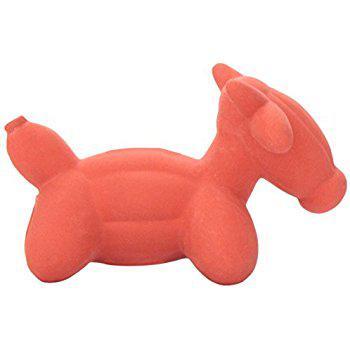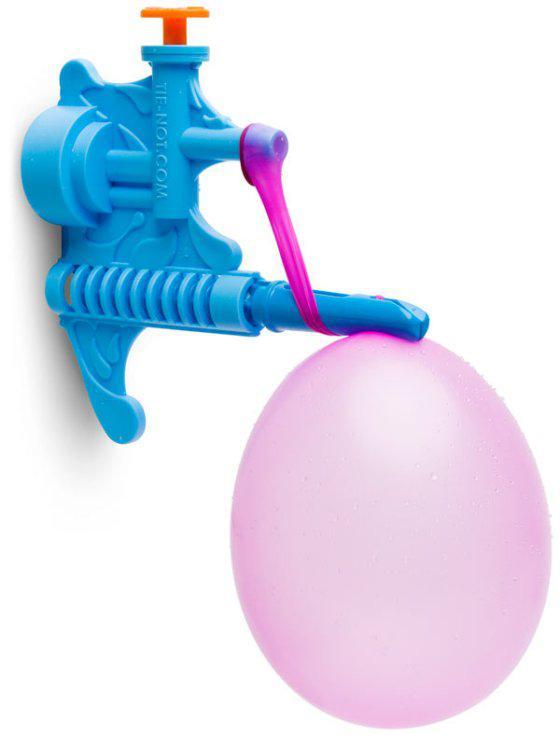The first image is the image on the left, the second image is the image on the right. For the images shown, is this caption "there is one blue balloon in a shape of a dog facing left" true? Answer yes or no. No. 